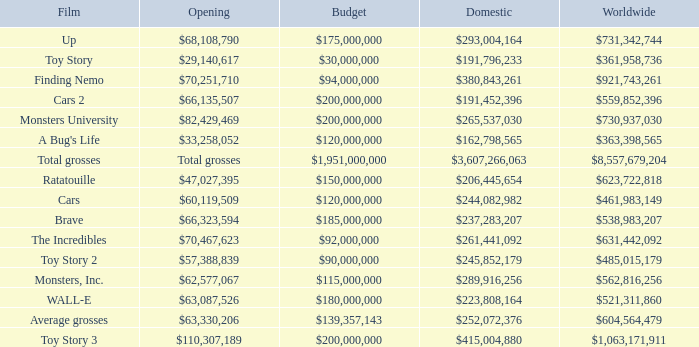WHAT IS THE BUDGET WHEN THE WORLDWIDE BOX OFFICE IS $363,398,565? $120,000,000. Can you give me this table as a dict? {'header': ['Film', 'Opening', 'Budget', 'Domestic', 'Worldwide'], 'rows': [['Up', '$68,108,790', '$175,000,000', '$293,004,164', '$731,342,744'], ['Toy Story', '$29,140,617', '$30,000,000', '$191,796,233', '$361,958,736'], ['Finding Nemo', '$70,251,710', '$94,000,000', '$380,843,261', '$921,743,261'], ['Cars 2', '$66,135,507', '$200,000,000', '$191,452,396', '$559,852,396'], ['Monsters University', '$82,429,469', '$200,000,000', '$265,537,030', '$730,937,030'], ["A Bug's Life", '$33,258,052', '$120,000,000', '$162,798,565', '$363,398,565'], ['Total grosses', 'Total grosses', '$1,951,000,000', '$3,607,266,063', '$8,557,679,204'], ['Ratatouille', '$47,027,395', '$150,000,000', '$206,445,654', '$623,722,818'], ['Cars', '$60,119,509', '$120,000,000', '$244,082,982', '$461,983,149'], ['Brave', '$66,323,594', '$185,000,000', '$237,283,207', '$538,983,207'], ['The Incredibles', '$70,467,623', '$92,000,000', '$261,441,092', '$631,442,092'], ['Toy Story 2', '$57,388,839', '$90,000,000', '$245,852,179', '$485,015,179'], ['Monsters, Inc.', '$62,577,067', '$115,000,000', '$289,916,256', '$562,816,256'], ['WALL-E', '$63,087,526', '$180,000,000', '$223,808,164', '$521,311,860'], ['Average grosses', '$63,330,206', '$139,357,143', '$252,072,376', '$604,564,479'], ['Toy Story 3', '$110,307,189', '$200,000,000', '$415,004,880', '$1,063,171,911']]} 